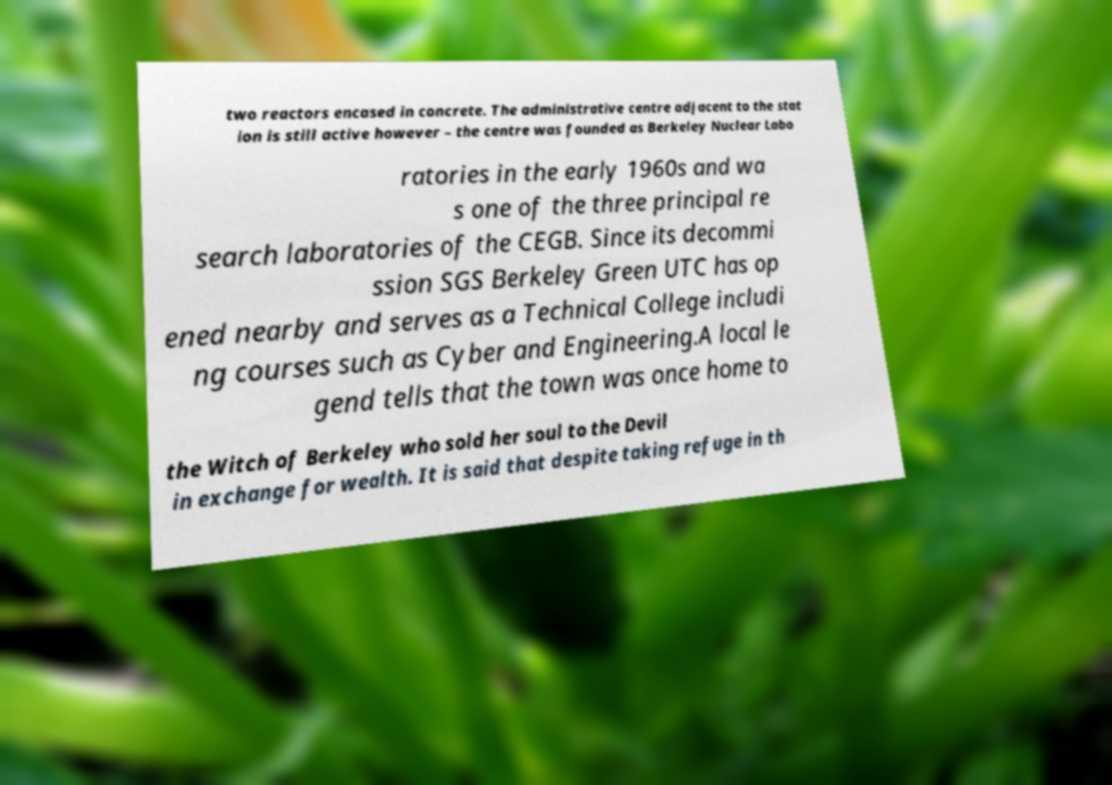Can you read and provide the text displayed in the image?This photo seems to have some interesting text. Can you extract and type it out for me? two reactors encased in concrete. The administrative centre adjacent to the stat ion is still active however – the centre was founded as Berkeley Nuclear Labo ratories in the early 1960s and wa s one of the three principal re search laboratories of the CEGB. Since its decommi ssion SGS Berkeley Green UTC has op ened nearby and serves as a Technical College includi ng courses such as Cyber and Engineering.A local le gend tells that the town was once home to the Witch of Berkeley who sold her soul to the Devil in exchange for wealth. It is said that despite taking refuge in th 